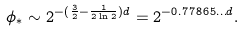<formula> <loc_0><loc_0><loc_500><loc_500>\phi _ { * } \sim 2 ^ { - ( \frac { 3 } { 2 } - \frac { 1 } { 2 \ln 2 } ) d } = 2 ^ { - 0 . 7 7 8 6 5 \dots d } .</formula> 